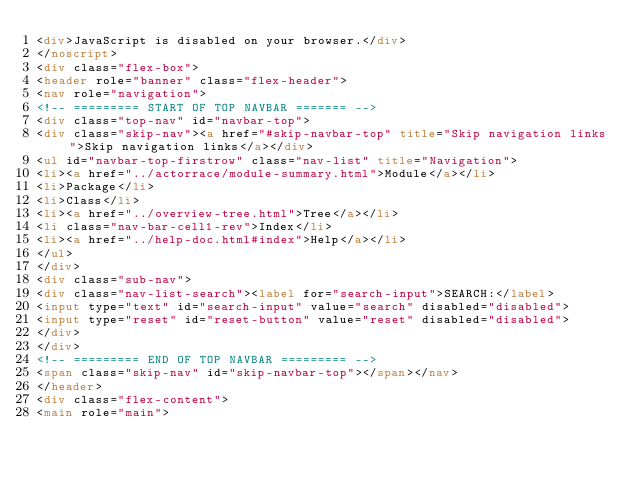<code> <loc_0><loc_0><loc_500><loc_500><_HTML_><div>JavaScript is disabled on your browser.</div>
</noscript>
<div class="flex-box">
<header role="banner" class="flex-header">
<nav role="navigation">
<!-- ========= START OF TOP NAVBAR ======= -->
<div class="top-nav" id="navbar-top">
<div class="skip-nav"><a href="#skip-navbar-top" title="Skip navigation links">Skip navigation links</a></div>
<ul id="navbar-top-firstrow" class="nav-list" title="Navigation">
<li><a href="../actorrace/module-summary.html">Module</a></li>
<li>Package</li>
<li>Class</li>
<li><a href="../overview-tree.html">Tree</a></li>
<li class="nav-bar-cell1-rev">Index</li>
<li><a href="../help-doc.html#index">Help</a></li>
</ul>
</div>
<div class="sub-nav">
<div class="nav-list-search"><label for="search-input">SEARCH:</label>
<input type="text" id="search-input" value="search" disabled="disabled">
<input type="reset" id="reset-button" value="reset" disabled="disabled">
</div>
</div>
<!-- ========= END OF TOP NAVBAR ========= -->
<span class="skip-nav" id="skip-navbar-top"></span></nav>
</header>
<div class="flex-content">
<main role="main"></code> 